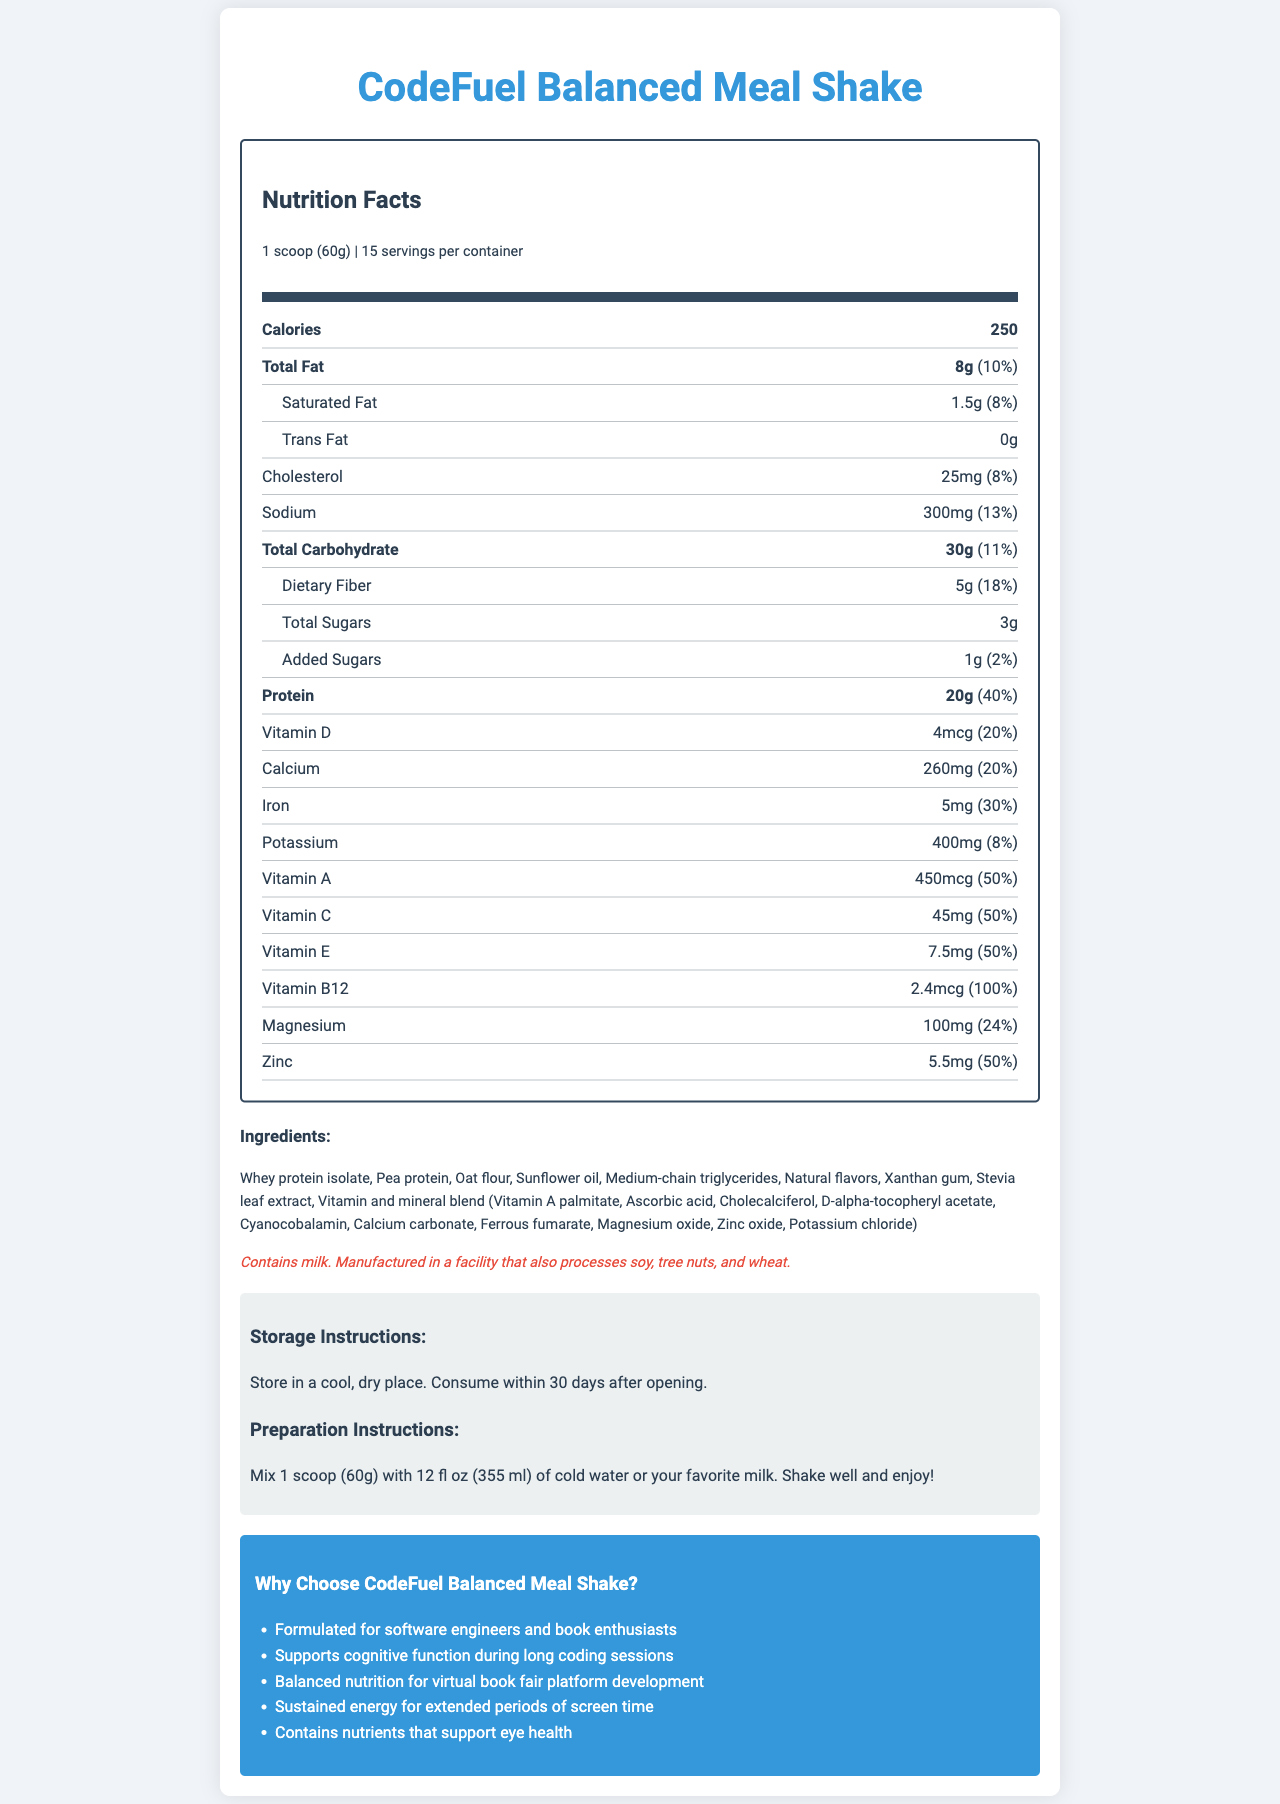How many servings are there per container of CodeFuel Balanced Meal Shake? The document states that there are 15 servings per container.
Answer: 15 What is the serving size of the meal replacement shake? The serving size is clearly mentioned at the top of the nutrition facts section.
Answer: 1 scoop (60g) How many calories are in one serving of the shake? The number of calories per serving is listed in the nutrition facts as 250.
Answer: 250 What is the total fat content per serving? The total fat content is listed as 8g in the nutrition facts.
Answer: 8g What percentage of the daily value does the protein content represent? The document states that the protein daily value percentage is 40%.
Answer: 40% Which vitamin has the highest daily value percentage? 
1. Vitamin D
2. Vitamin B12
3. Vitamin A
4. Vitamin C Vitamin B12 has a daily value percentage of 100%, which is higher compared to other listed vitamins.
Answer: 2. Vitamin B12 How much sodium does one serving contain?
A. 200mg
B. 250mg
C. 300mg
D. 350mg The nutrition facts label states that one serving contains 300mg of sodium.
Answer: C. 300mg Does the shake contain any trans fat? The document indicates that the shake contains 0g of trans fat.
Answer: No Is the CodeFuel Balanced Meal Shake suitable for someone with a milk allergy? The allergen information clearly states that the product contains milk.
Answer: No Summarize what nutrients are present in the CodeFuel Balanced Meal Shake and their general benefits. The summary should highlight that the shake includes a balanced mix of macronutrients (protein, fats, carbohydrates) and essential micronutrients (various vitamins and minerals) beneficial for sustained energy and cognitive and visual health, particularly emphasizing its suitability for demanding tasks such as long coding sessions and extensive screen time.
Answer: The CodeFuel Balanced Meal Shake contains essential vitamins and minerals, including high protein (20g), vitamins A, C, D, E, and B12, calcium, iron, potassium, magnesium, and zinc. It offers balanced nutrition ideal for long hours of work and screen time, with nutrients supporting cognitive function and eye health. Can you determine the flavor of the CodeFuel Balanced Meal Shake from the document? The document does not specify the flavor, it simply lists "Natural flavors" in the ingredients, which does not describe the specific taste of the shake.
Answer: Not enough information What are the overall marketing claims made about the CodeFuel Balanced Meal Shake? These claims are found under the marketing claims section toward the end of the document and highlight the target audience and the specific benefits the product aims to provide.
Answer: The shake is marketed as being formulated specifically for software engineers and book enthusiasts, supporting cognitive function during long coding sessions, providing balanced nutrition for virtual book fair platform development, offering sustained energy for extended periods of screen time, and containing nutrients that support eye health. What are the main ingredients of the shake? Name at least three. The ingredients section lists whey protein isolate, pea protein, and oat flour among the several main components.
Answer: Whey protein isolate, Pea protein, Oat flour 